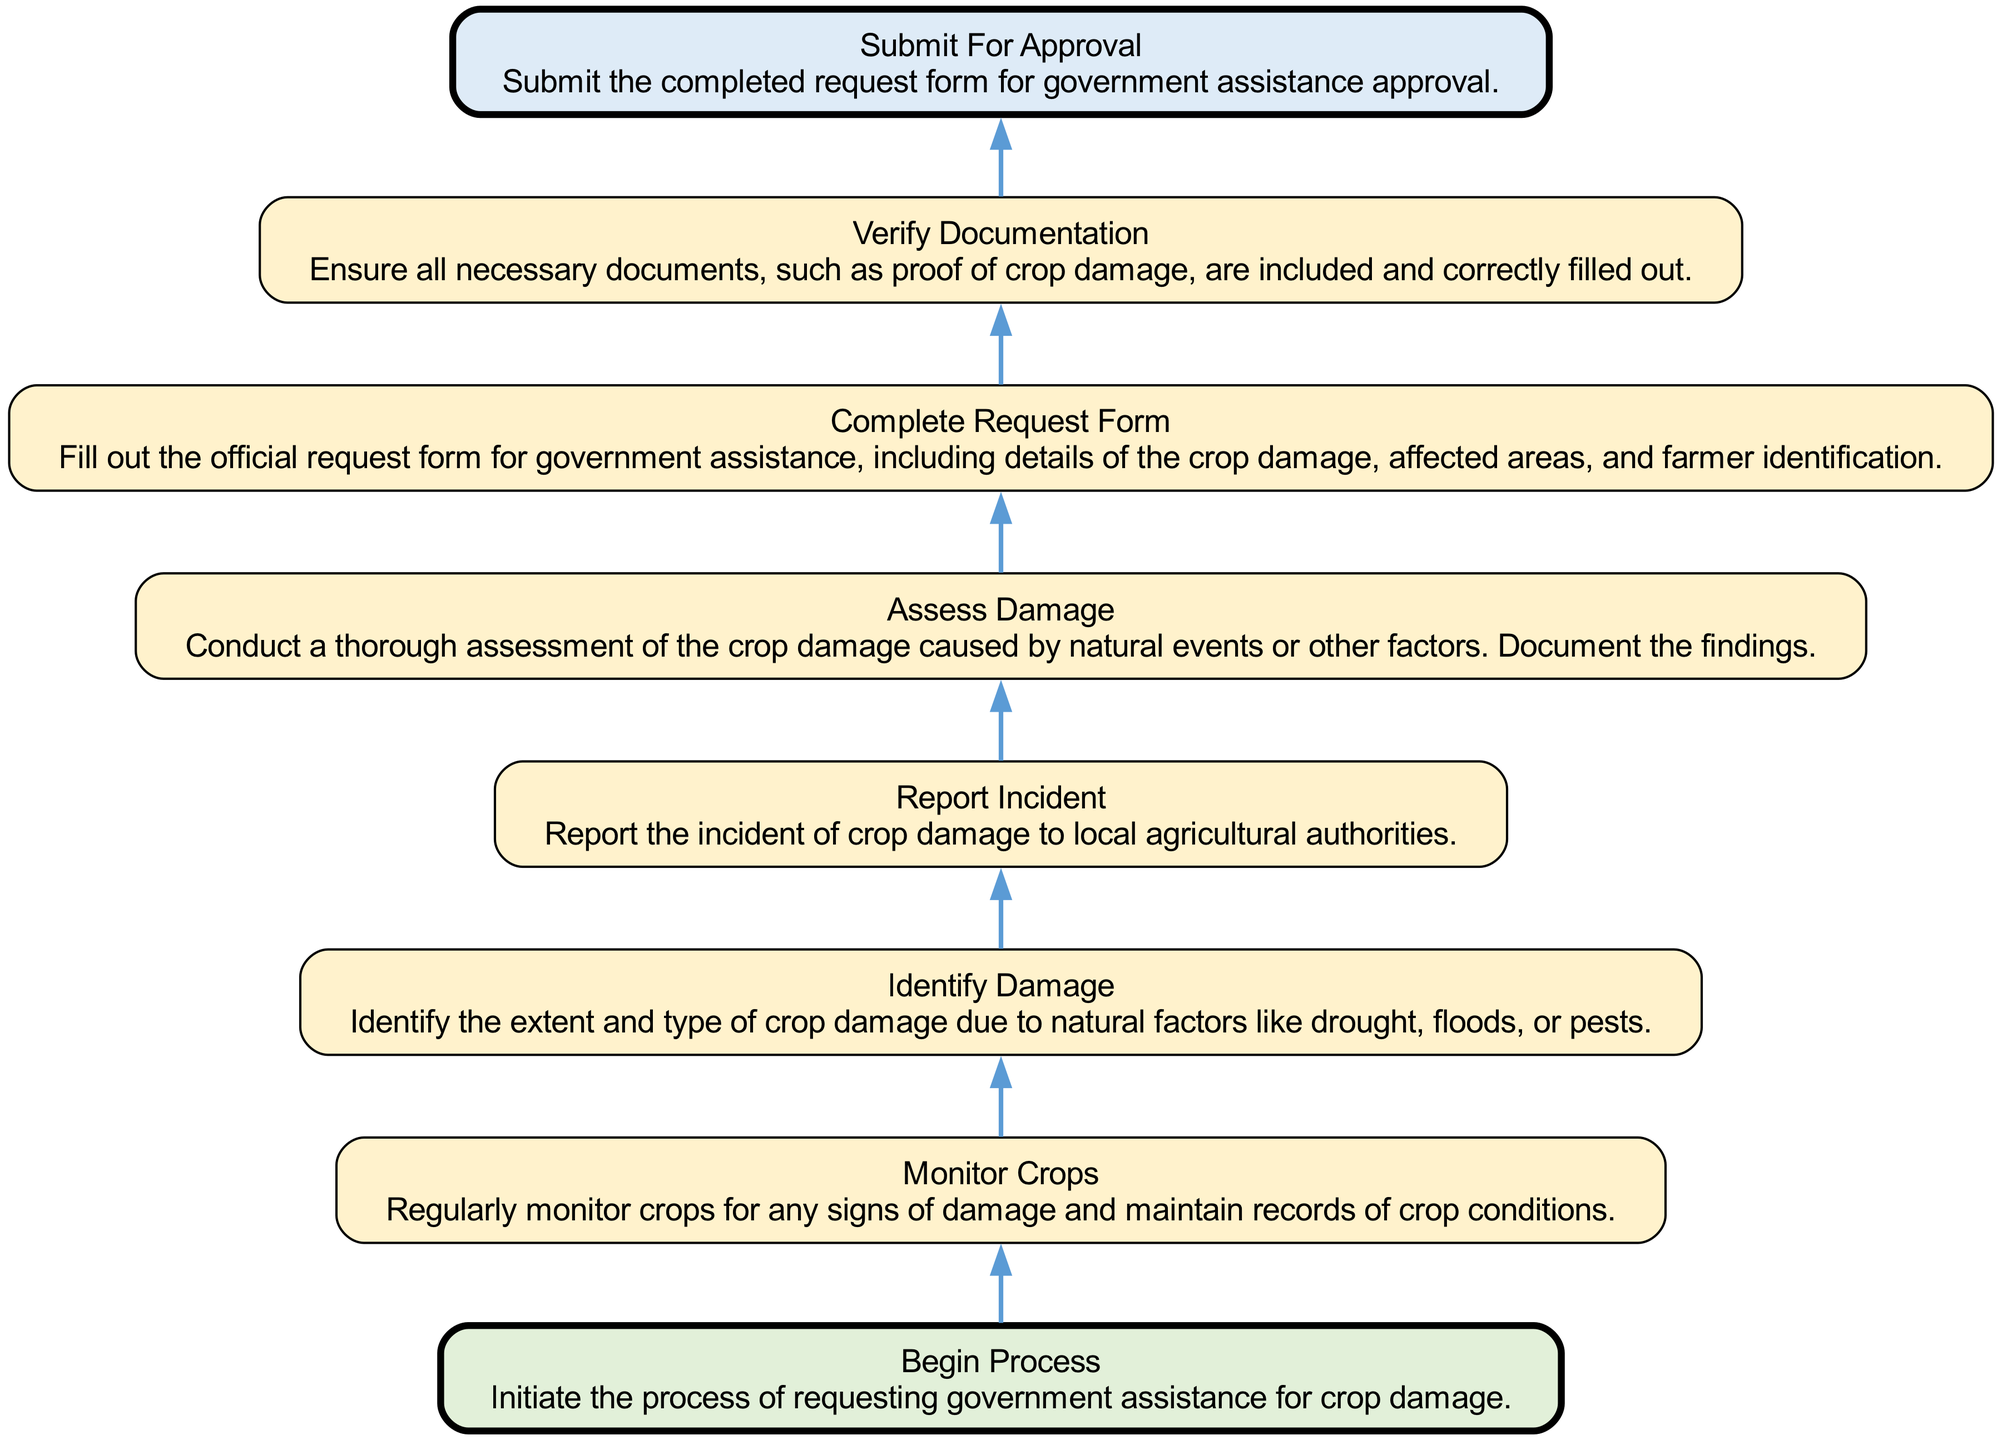What's the first step in the flowchart? The first step in the flowchart is labeled "Begin Process," which initiates the process of requesting government assistance for crop damage. This node is positioned at the bottom of the diagram, indicating it is the starting point.
Answer: Begin Process What is the last step before submitting the request for approval? The last step before submitting the request for approval is "Verify Documentation." This step ensures that all necessary documents are included and correctly filled out. It directly precedes the "Submit For Approval" step in the flowchart.
Answer: Verify Documentation How many steps are involved in the process? There are a total of eight steps involved in the process, as indicated by the eight distinct elements listed in the flowchart, from "Begin Process" to "Submit For Approval."
Answer: Eight Which step occurs after assessing damage? The step that occurs after "Assess Damage" is "Submit For Approval." This indicates that after conducting a thorough assessment of the crop damage, the next action is to submit the completed request form.
Answer: Submit For Approval What is the relationship between "Monitor Crops" and "Identify Damage"? "Monitor Crops" precedes "Identify Damage," indicating that regular monitoring of the crops is necessary before determining the extent and type of crop damage. This establishes a sequential relationship between the two steps.
Answer: Precedes Which step involves reporting the crop damage? The step that involves reporting the crop damage to local agricultural authorities is "Report Incident." This occurs after identifying the damage and is crucial for initiating the assistance request process.
Answer: Report Incident What documentation is necessary before submitting for approval? Before submitting for approval, it is necessary to have "Verify Documentation," which ensures that all required documents, including proof of crop damage, are included and correctly filled out. This step is critical for a successful approval process.
Answer: Verify Documentation What do the nodes in the flowchart represent? The nodes in the flowchart represent specific steps in the process of requesting government assistance for crop damage. Each node contains the name of the step and a brief description outlining its purpose.
Answer: Specific steps 